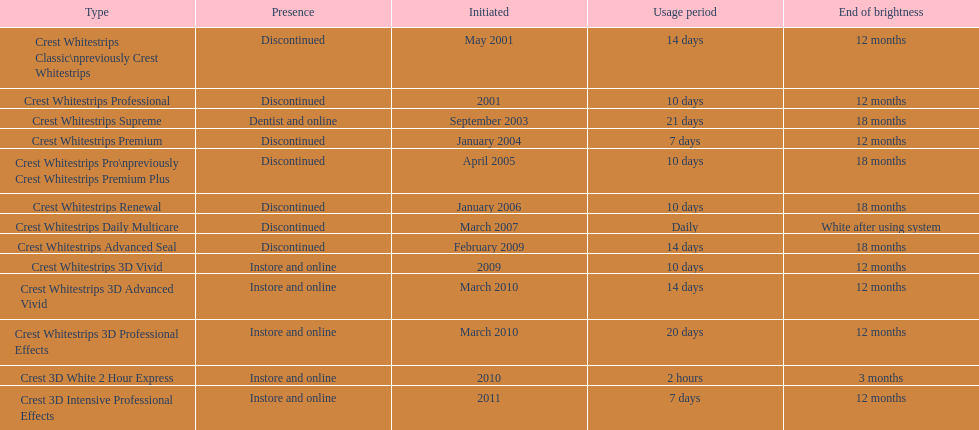How many models necessitate usage for less than a week? 2. 